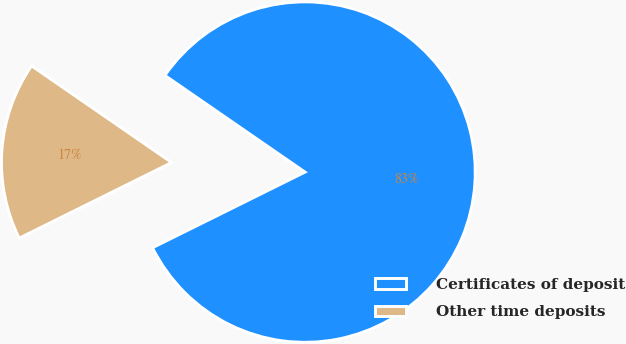<chart> <loc_0><loc_0><loc_500><loc_500><pie_chart><fcel>Certificates of deposit<fcel>Other time deposits<nl><fcel>83.06%<fcel>16.94%<nl></chart> 